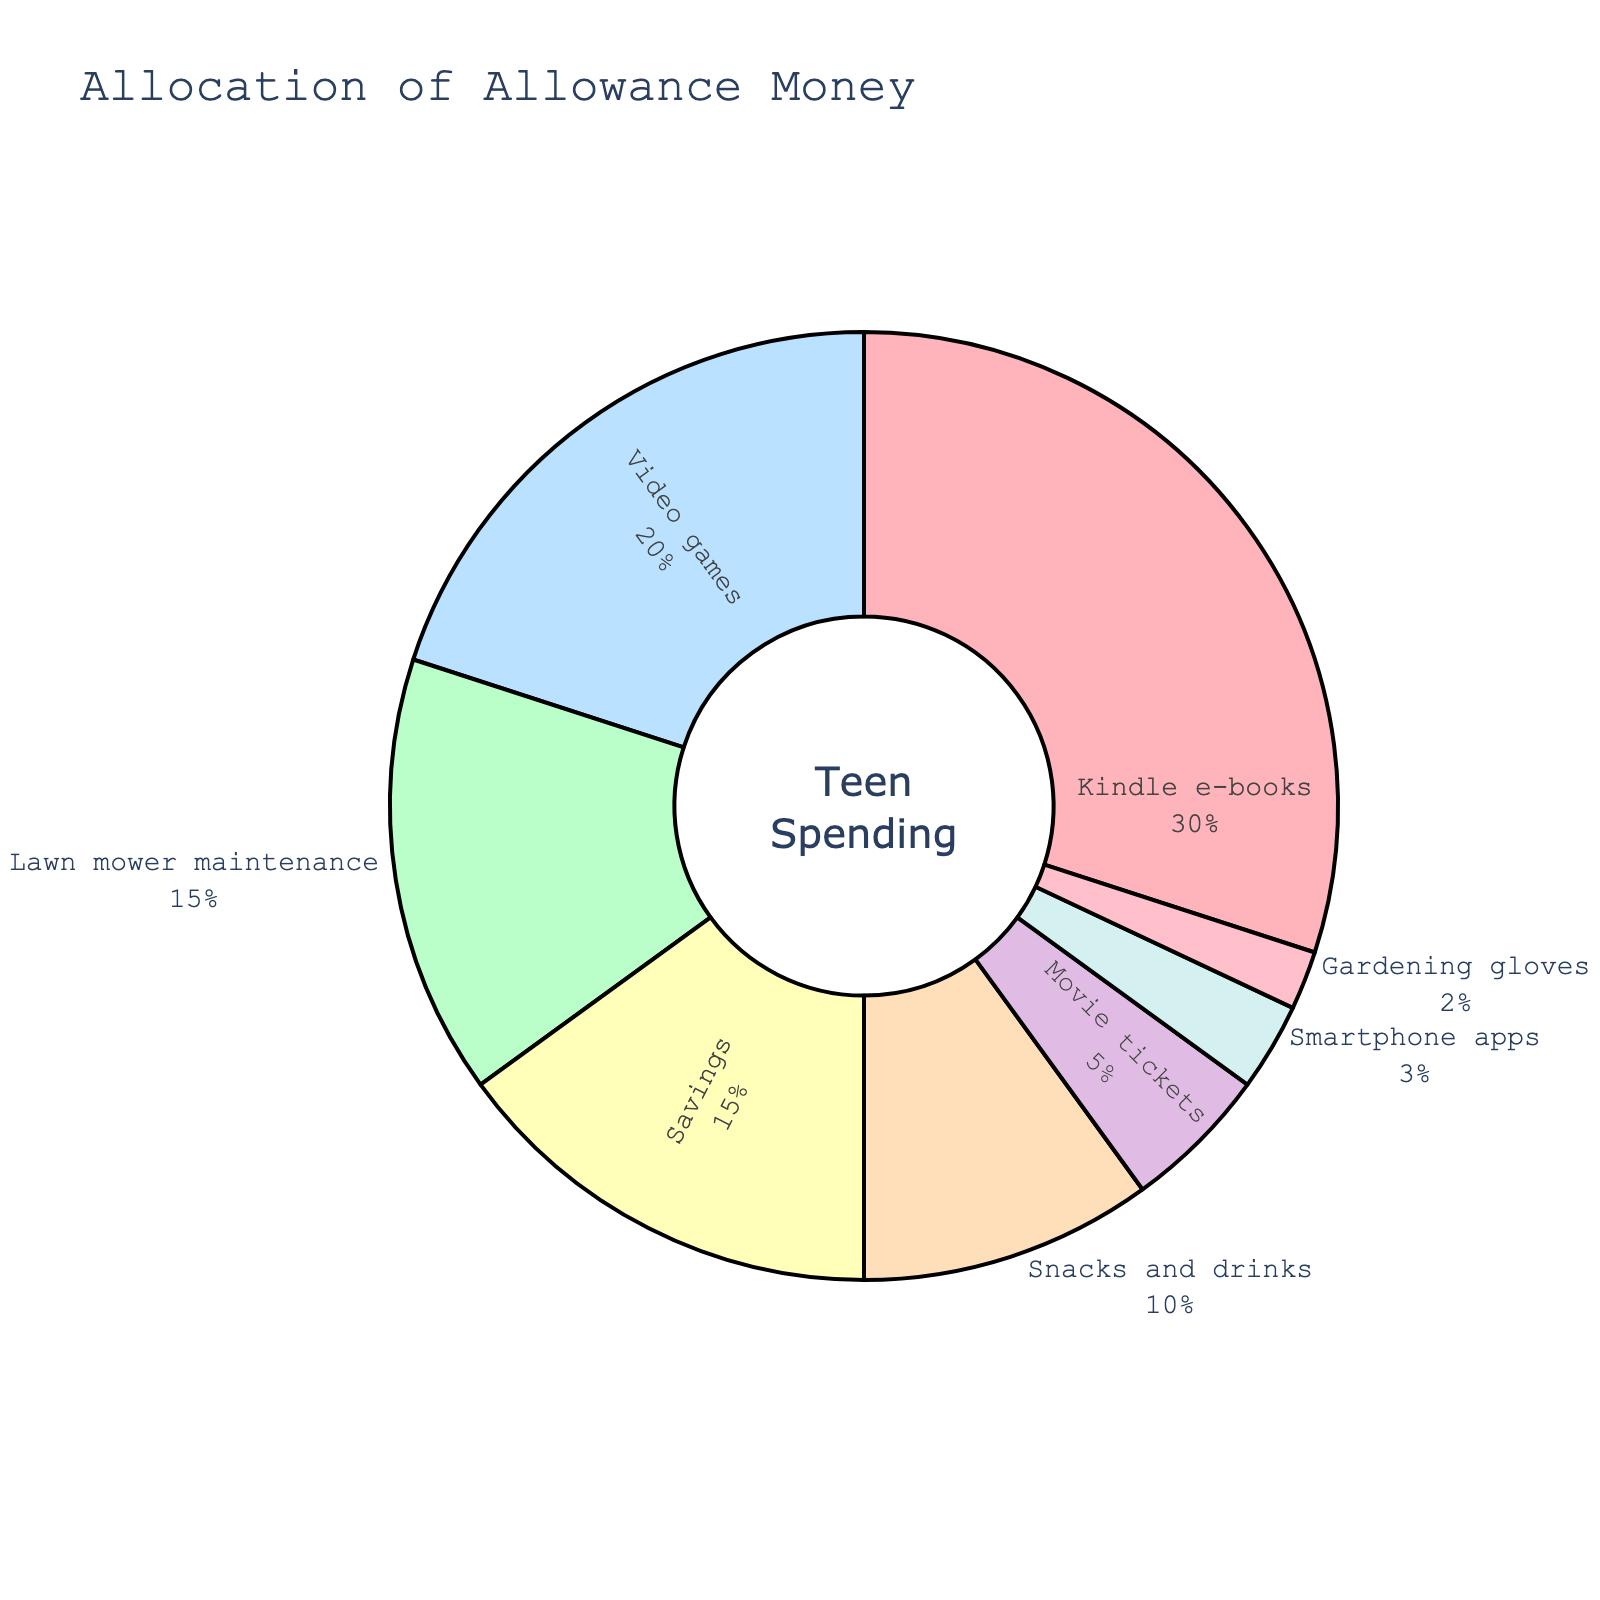Which category has the second-highest percentage of allowance money allocation? By looking at the pie chart, identify the category with the largest segment and then find the next largest segment. The largest segment is for "Kindle e-books" (30%), and the second largest segment is for "Video games" (20%).
Answer: Video games What is the combined percentage of allowance money allocated to Savings and Lawn mower maintenance? Add the percentages for both categories: Savings (15%) and Lawn mower maintenance (15%). The combined percentage is 15% + 15% = 30%.
Answer: 30% How much more percentage is allocated to Kindle e-books compared to Snacks and drinks? Subtract the percentage of Snacks and drinks (10%) from Kindle e-books (30%). The difference is 30% - 10% = 20%.
Answer: 20% Which category has the lowest percentage of allowance money allocation? Identify the smallest segment in the pie chart. The smallest segment is for "Gardening gloves" (2%).
Answer: Gardening gloves What is the total percentage allocated to Smartphone apps and Movie tickets? Add the percentages for both categories: Smartphone apps (3%) and Movie tickets (5%). The total percentage is 3% + 5% = 8%.
Answer: 8% Is the percentage allocated to Lawn mower maintenance greater than or less than the percentage for Savings? Compare the two percentages: Lawn mower maintenance (15%) and Savings (15%). Both percentages are equal.
Answer: Equal Which category has a higher percentage allocation: Video games or Snacks and drinks? Compare the two percentages: Video games (20%) and Snacks and drinks (10%). Video games have a higher percentage.
Answer: Video games What is the average percentage allocation for Kindle e-books, Video games, and Savings? Calculate the average by adding the percentages and dividing by the number of categories: (30% + 20% + 15%) / 3 = 65% / 3 ≈ 21.67%.
Answer: 21.67% What percentage of allowance money is allocated to categories with double-digit percentages? Sum the percentages of categories with double-digit values: Kindle e-books (30%), Video games (20%), Lawn mower maintenance (15%), Savings (15%), and Snacks and drinks (10%). The total is 30% + 20% + 15% + 15% + 10% = 90%.
Answer: 90% How does the percentage allocation for Movie tickets compare with that for Snacks and drinks? Compare the percentages of Movie tickets (5%) and Snacks and drinks (10%). Snacks and drinks have a higher percentage than Movie tickets.
Answer: Snacks and drinks 